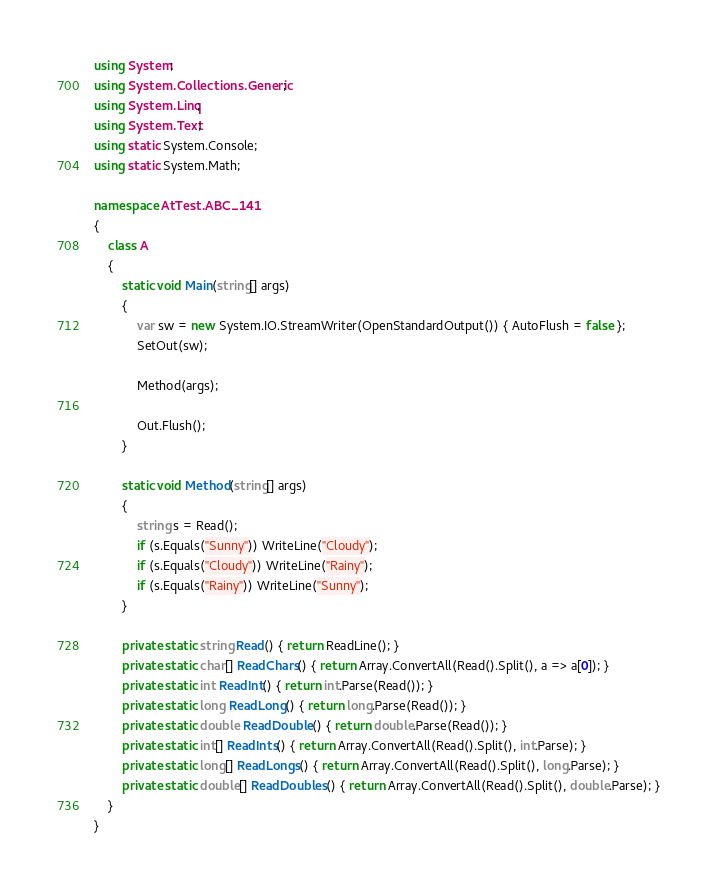Convert code to text. <code><loc_0><loc_0><loc_500><loc_500><_C#_>using System;
using System.Collections.Generic;
using System.Linq;
using System.Text;
using static System.Console;
using static System.Math;

namespace AtTest.ABC_141
{
    class A
    {
        static void Main(string[] args)
        {
            var sw = new System.IO.StreamWriter(OpenStandardOutput()) { AutoFlush = false };
            SetOut(sw);

            Method(args);

            Out.Flush();
        }

        static void Method(string[] args)
        {
            string s = Read();
            if (s.Equals("Sunny")) WriteLine("Cloudy");
            if (s.Equals("Cloudy")) WriteLine("Rainy");
            if (s.Equals("Rainy")) WriteLine("Sunny");
        }

        private static string Read() { return ReadLine(); }
        private static char[] ReadChars() { return Array.ConvertAll(Read().Split(), a => a[0]); }
        private static int ReadInt() { return int.Parse(Read()); }
        private static long ReadLong() { return long.Parse(Read()); }
        private static double ReadDouble() { return double.Parse(Read()); }
        private static int[] ReadInts() { return Array.ConvertAll(Read().Split(), int.Parse); }
        private static long[] ReadLongs() { return Array.ConvertAll(Read().Split(), long.Parse); }
        private static double[] ReadDoubles() { return Array.ConvertAll(Read().Split(), double.Parse); }
    }
}
</code> 